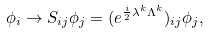Convert formula to latex. <formula><loc_0><loc_0><loc_500><loc_500>\phi _ { i } \rightarrow S _ { i j } \phi _ { j } = ( e ^ { \frac { i } { 2 } \lambda ^ { k } \Lambda ^ { k } } ) _ { i j } \phi _ { j } ,</formula> 